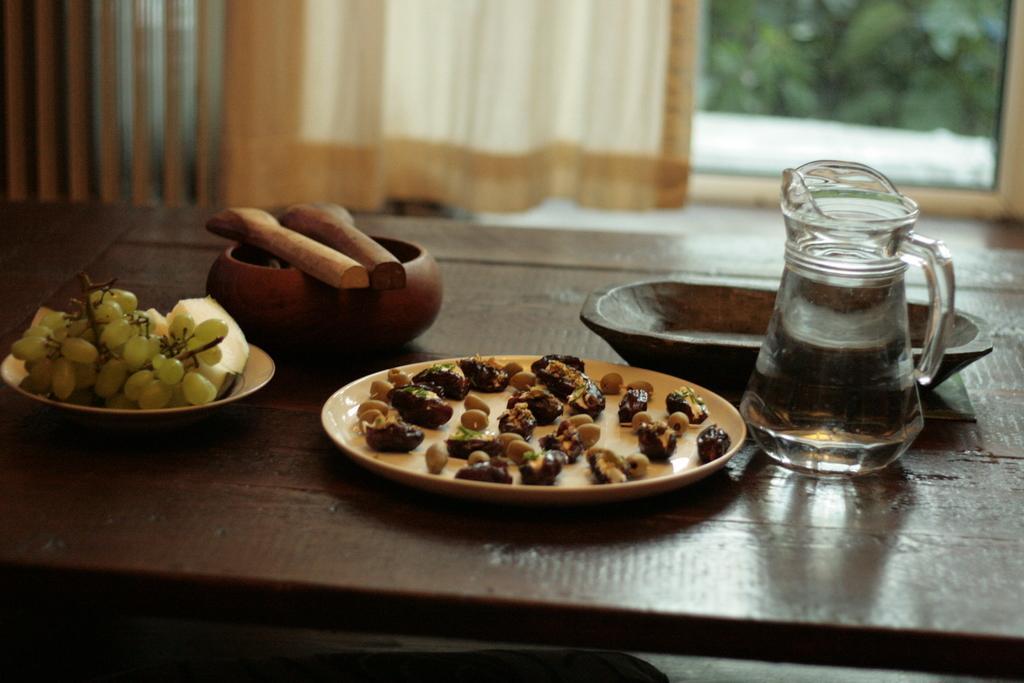Describe this image in one or two sentences. On this table there is a tray, bowl, plates and jar with water. On this plates there are fruits and food. This is window with curtain. From this window we can able to see tree. 